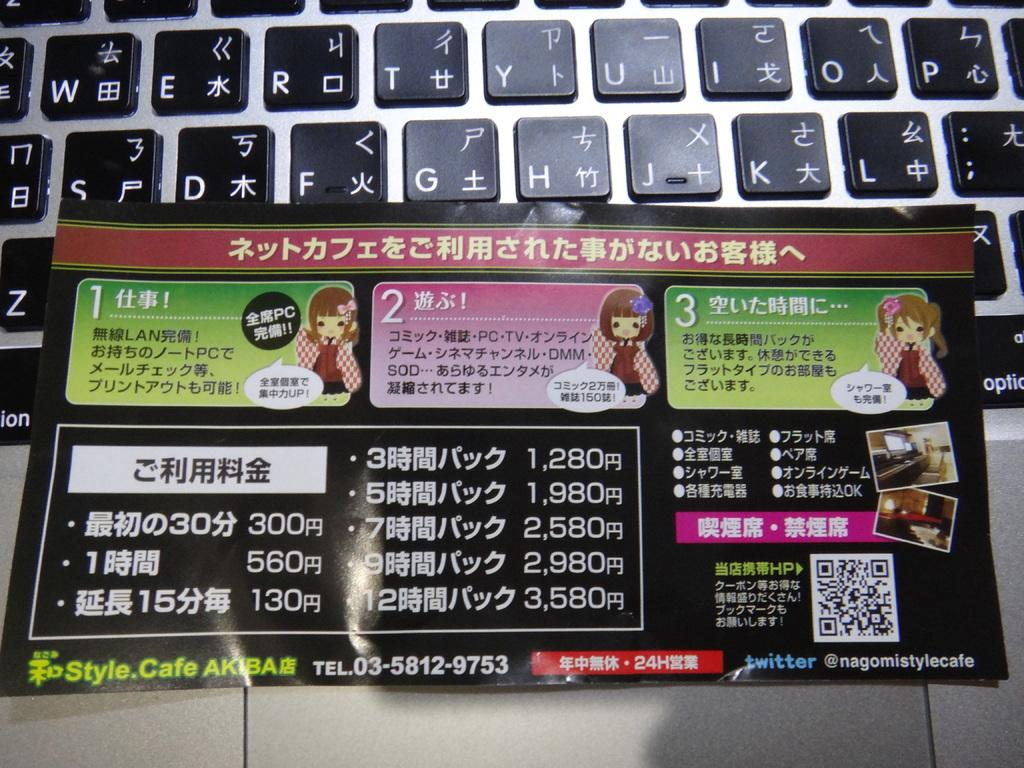<image>
Summarize the visual content of the image. A card printed in a foreign language for @nagomiststylecafe is sitting in front of a keyboard. 